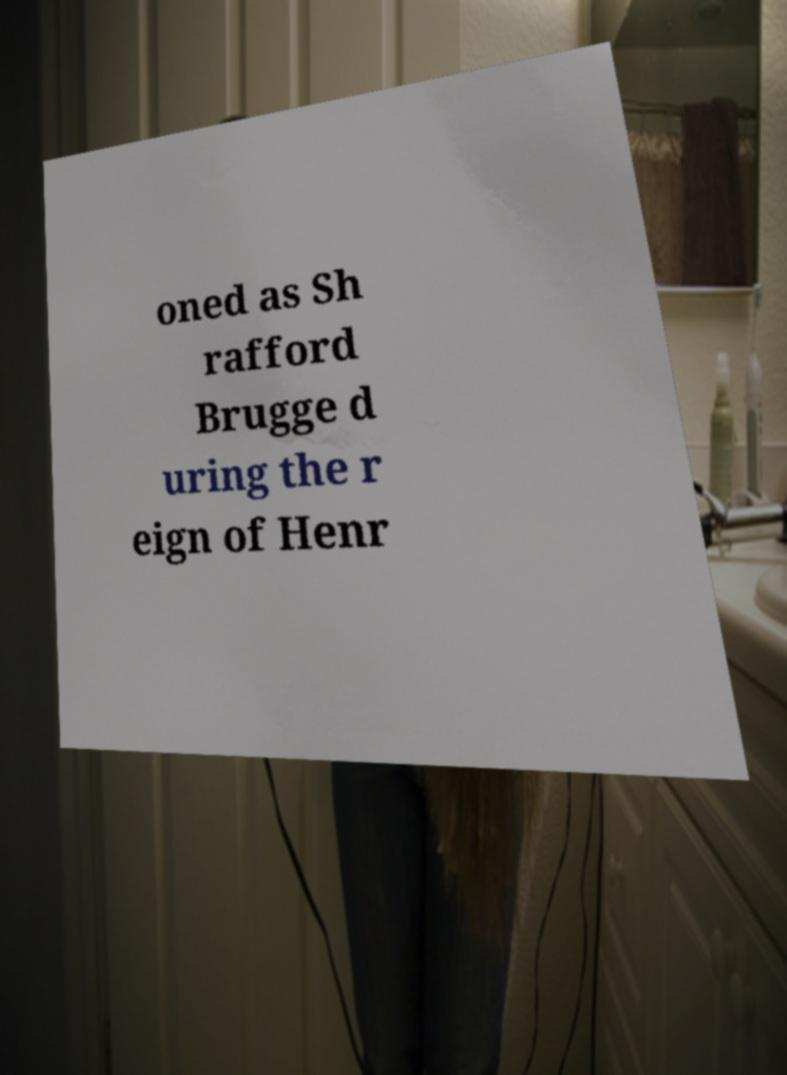I need the written content from this picture converted into text. Can you do that? oned as Sh rafford Brugge d uring the r eign of Henr 